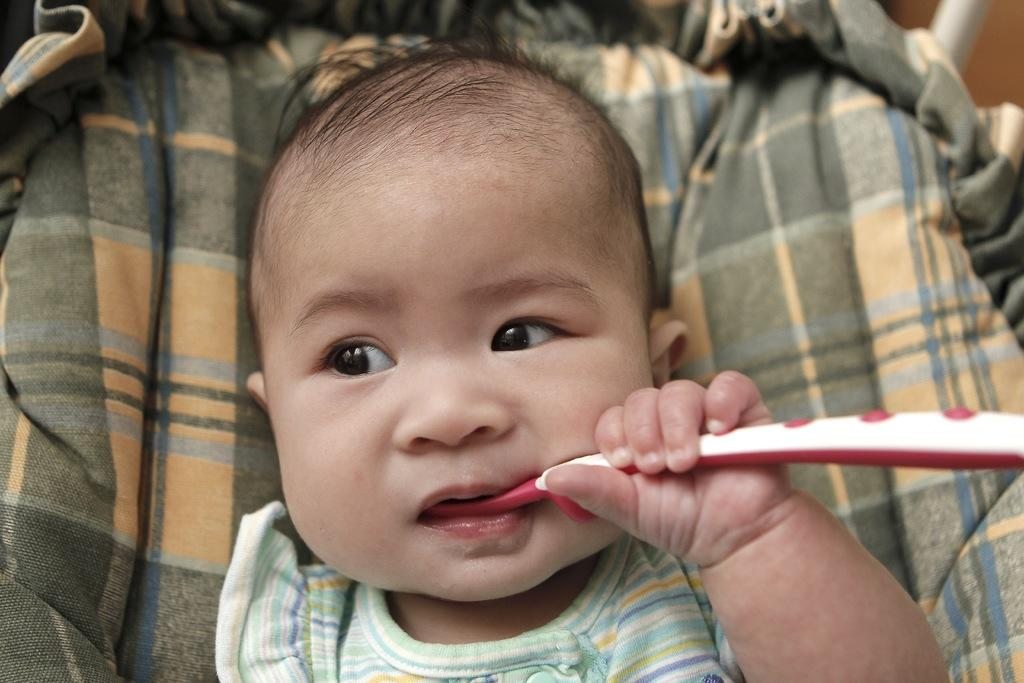What is the main subject of the image? There is a baby in the center of the image. What is the baby holding in the image? The baby is holding a brush. Can you describe anything visible in the background of the image? There is a cloth visible in the background of the image. How many beans are on the baby's head in the image? There are no beans present in the image; the baby is holding a brush. What type of trouble is the baby causing in the image? There is no indication of trouble in the image; the baby is simply holding a brush. 